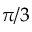Convert formula to latex. <formula><loc_0><loc_0><loc_500><loc_500>\pi / 3</formula> 